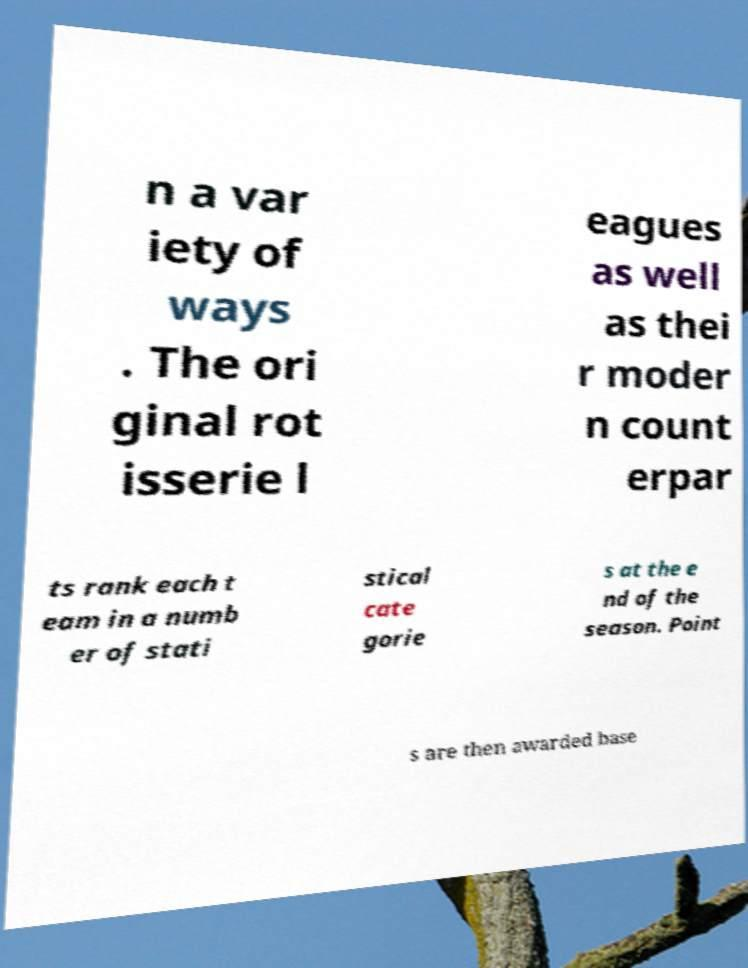Please read and relay the text visible in this image. What does it say? n a var iety of ways . The ori ginal rot isserie l eagues as well as thei r moder n count erpar ts rank each t eam in a numb er of stati stical cate gorie s at the e nd of the season. Point s are then awarded base 